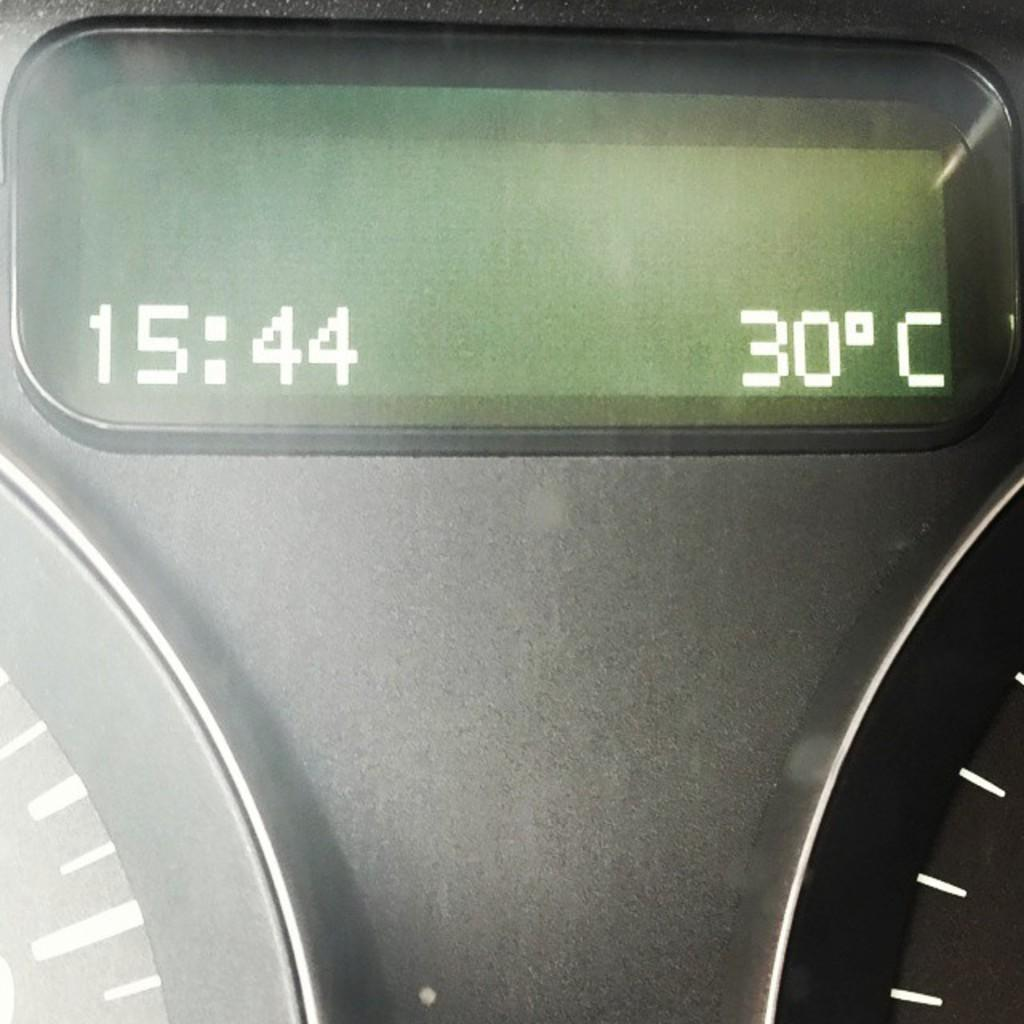Provide a one-sentence caption for the provided image. The screen on a vehicles dashboard says that the time is 15:44 and the temperature is 30C. 